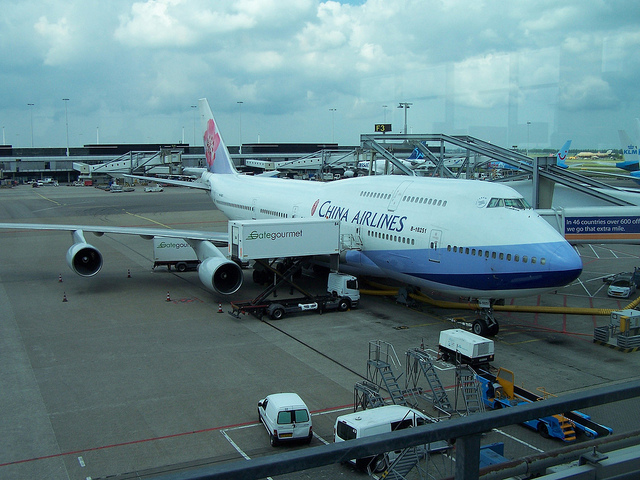<image>What letters are on the green and brown plane? There is no green and brown plane in the image. However, it might be 'China Airlines' or 'Central Airlines'. What letters are on the green and brown plane? I don't know what letters are on the green and brown plane. It can be seen 'china airlines' or 'central airlines'. 